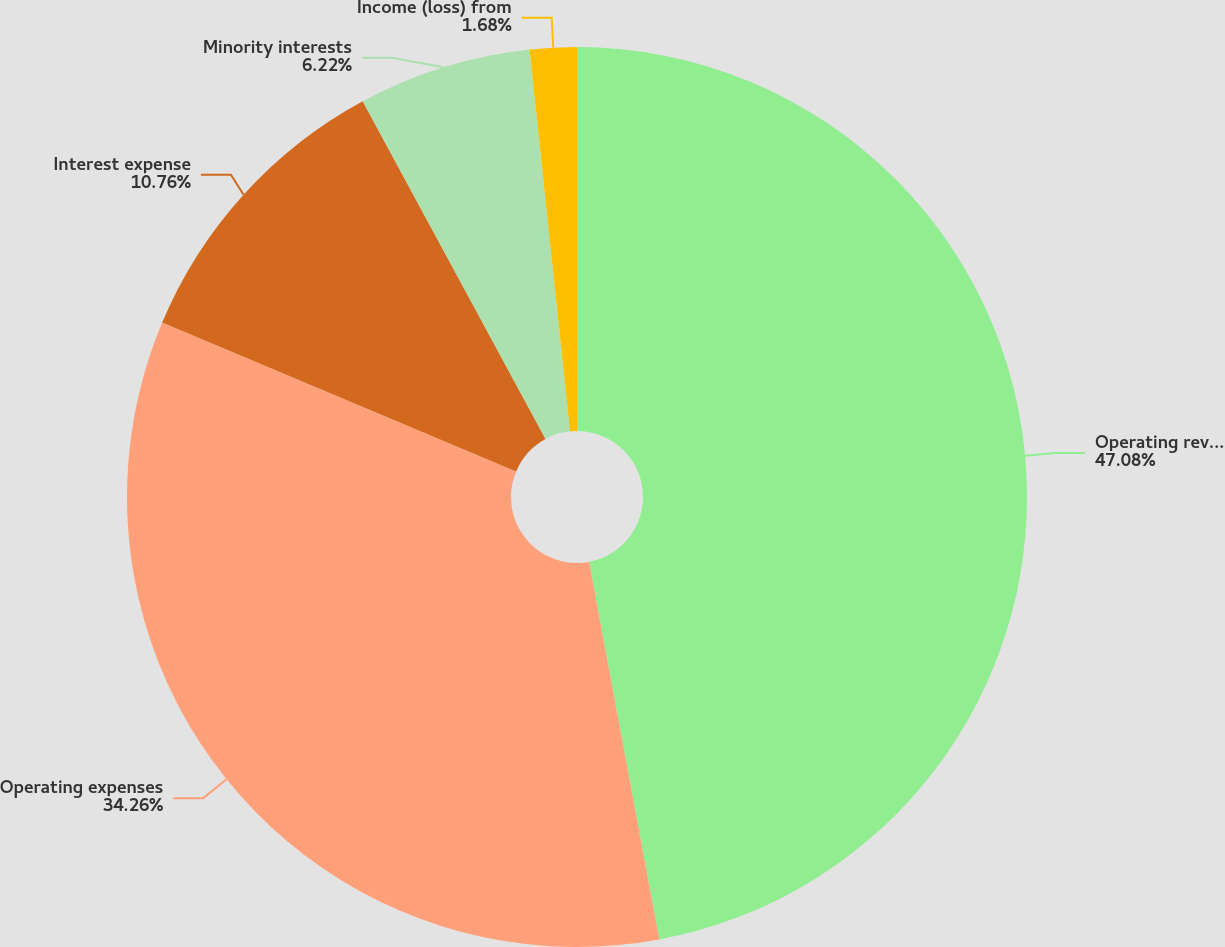Convert chart to OTSL. <chart><loc_0><loc_0><loc_500><loc_500><pie_chart><fcel>Operating revenues<fcel>Operating expenses<fcel>Interest expense<fcel>Minority interests<fcel>Income (loss) from<nl><fcel>47.07%<fcel>34.26%<fcel>10.76%<fcel>6.22%<fcel>1.68%<nl></chart> 